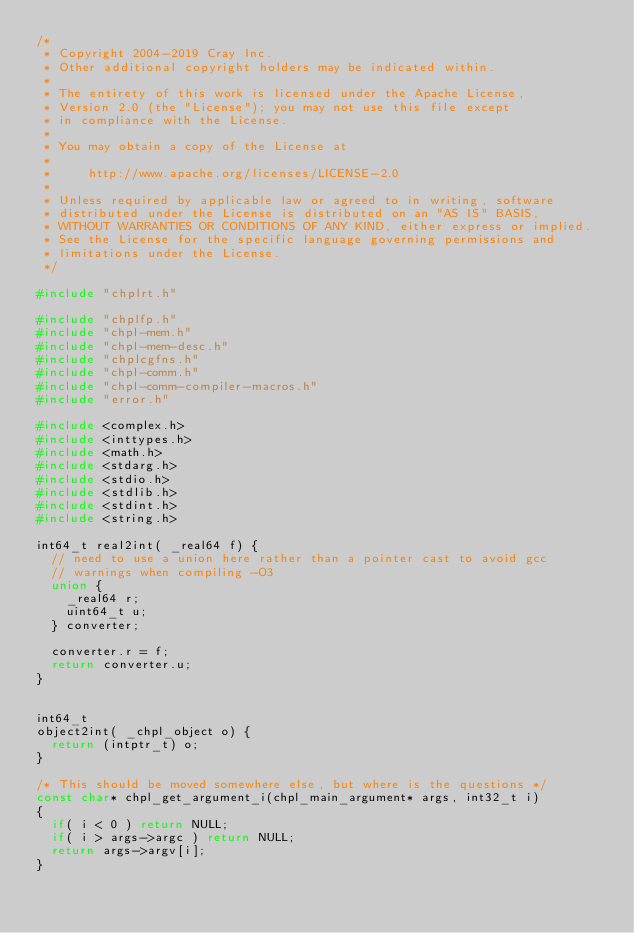Convert code to text. <code><loc_0><loc_0><loc_500><loc_500><_C_>/*
 * Copyright 2004-2019 Cray Inc.
 * Other additional copyright holders may be indicated within.
 * 
 * The entirety of this work is licensed under the Apache License,
 * Version 2.0 (the "License"); you may not use this file except
 * in compliance with the License.
 * 
 * You may obtain a copy of the License at
 * 
 *     http://www.apache.org/licenses/LICENSE-2.0
 * 
 * Unless required by applicable law or agreed to in writing, software
 * distributed under the License is distributed on an "AS IS" BASIS,
 * WITHOUT WARRANTIES OR CONDITIONS OF ANY KIND, either express or implied.
 * See the License for the specific language governing permissions and
 * limitations under the License.
 */

#include "chplrt.h"

#include "chplfp.h"
#include "chpl-mem.h"
#include "chpl-mem-desc.h"
#include "chplcgfns.h"
#include "chpl-comm.h"
#include "chpl-comm-compiler-macros.h"
#include "error.h"

#include <complex.h>
#include <inttypes.h>
#include <math.h>
#include <stdarg.h>
#include <stdio.h>
#include <stdlib.h>
#include <stdint.h>
#include <string.h>

int64_t real2int( _real64 f) {
  // need to use a union here rather than a pointer cast to avoid gcc
  // warnings when compiling -O3
  union {
    _real64 r;
    uint64_t u;
  } converter;

  converter.r = f;
  return converter.u;
}


int64_t
object2int( _chpl_object o) {
  return (intptr_t) o;
}

/* This should be moved somewhere else, but where is the questions */
const char* chpl_get_argument_i(chpl_main_argument* args, int32_t i)
{
  if( i < 0 ) return NULL;
  if( i > args->argc ) return NULL;
  return args->argv[i];
}

</code> 